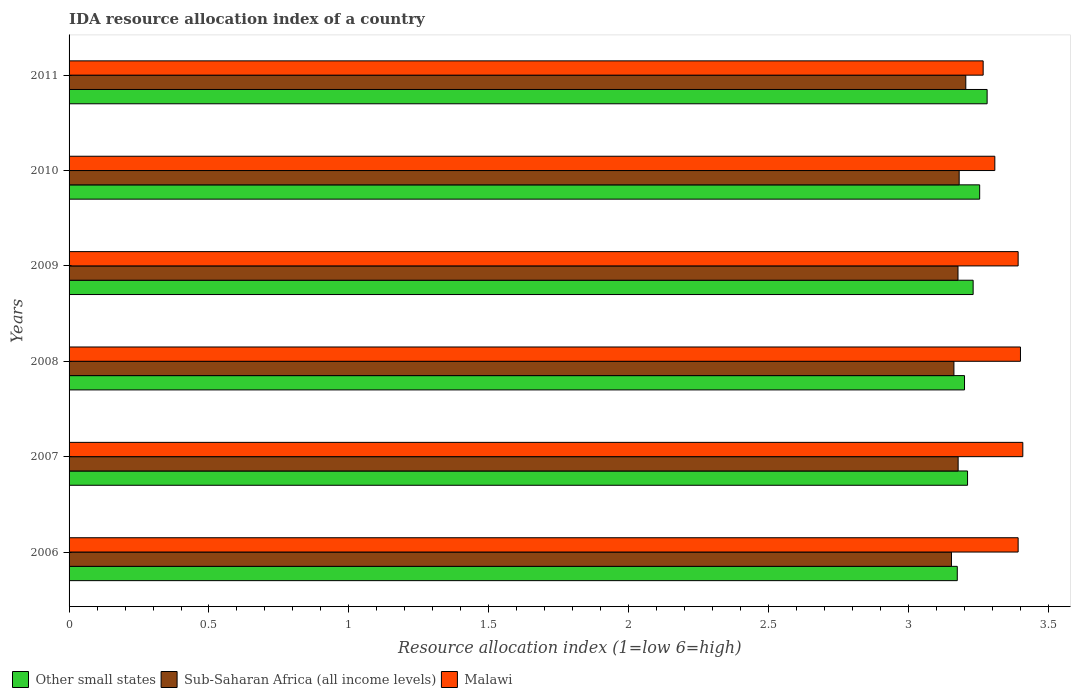Are the number of bars per tick equal to the number of legend labels?
Make the answer very short. Yes. Are the number of bars on each tick of the Y-axis equal?
Make the answer very short. Yes. How many bars are there on the 1st tick from the top?
Provide a short and direct response. 3. What is the label of the 1st group of bars from the top?
Your answer should be compact. 2011. In how many cases, is the number of bars for a given year not equal to the number of legend labels?
Offer a terse response. 0. Across all years, what is the maximum IDA resource allocation index in Other small states?
Your response must be concise. 3.28. Across all years, what is the minimum IDA resource allocation index in Other small states?
Your answer should be very brief. 3.17. What is the total IDA resource allocation index in Malawi in the graph?
Your response must be concise. 20.17. What is the difference between the IDA resource allocation index in Sub-Saharan Africa (all income levels) in 2006 and that in 2011?
Make the answer very short. -0.05. What is the difference between the IDA resource allocation index in Other small states in 2006 and the IDA resource allocation index in Malawi in 2011?
Make the answer very short. -0.09. What is the average IDA resource allocation index in Malawi per year?
Offer a very short reply. 3.36. In the year 2010, what is the difference between the IDA resource allocation index in Other small states and IDA resource allocation index in Sub-Saharan Africa (all income levels)?
Keep it short and to the point. 0.07. What is the ratio of the IDA resource allocation index in Sub-Saharan Africa (all income levels) in 2008 to that in 2009?
Your response must be concise. 1. Is the difference between the IDA resource allocation index in Other small states in 2006 and 2010 greater than the difference between the IDA resource allocation index in Sub-Saharan Africa (all income levels) in 2006 and 2010?
Give a very brief answer. No. What is the difference between the highest and the second highest IDA resource allocation index in Other small states?
Offer a terse response. 0.03. What is the difference between the highest and the lowest IDA resource allocation index in Malawi?
Keep it short and to the point. 0.14. What does the 3rd bar from the top in 2009 represents?
Your answer should be compact. Other small states. What does the 2nd bar from the bottom in 2007 represents?
Ensure brevity in your answer.  Sub-Saharan Africa (all income levels). Is it the case that in every year, the sum of the IDA resource allocation index in Other small states and IDA resource allocation index in Sub-Saharan Africa (all income levels) is greater than the IDA resource allocation index in Malawi?
Offer a terse response. Yes. How many bars are there?
Ensure brevity in your answer.  18. What is the difference between two consecutive major ticks on the X-axis?
Make the answer very short. 0.5. Are the values on the major ticks of X-axis written in scientific E-notation?
Your answer should be compact. No. Does the graph contain any zero values?
Ensure brevity in your answer.  No. Does the graph contain grids?
Offer a terse response. No. How are the legend labels stacked?
Your answer should be very brief. Horizontal. What is the title of the graph?
Offer a very short reply. IDA resource allocation index of a country. Does "Maldives" appear as one of the legend labels in the graph?
Give a very brief answer. No. What is the label or title of the X-axis?
Provide a short and direct response. Resource allocation index (1=low 6=high). What is the Resource allocation index (1=low 6=high) in Other small states in 2006?
Give a very brief answer. 3.17. What is the Resource allocation index (1=low 6=high) of Sub-Saharan Africa (all income levels) in 2006?
Your response must be concise. 3.15. What is the Resource allocation index (1=low 6=high) in Malawi in 2006?
Your answer should be very brief. 3.39. What is the Resource allocation index (1=low 6=high) of Other small states in 2007?
Your answer should be compact. 3.21. What is the Resource allocation index (1=low 6=high) in Sub-Saharan Africa (all income levels) in 2007?
Keep it short and to the point. 3.18. What is the Resource allocation index (1=low 6=high) of Malawi in 2007?
Offer a terse response. 3.41. What is the Resource allocation index (1=low 6=high) in Sub-Saharan Africa (all income levels) in 2008?
Make the answer very short. 3.16. What is the Resource allocation index (1=low 6=high) in Other small states in 2009?
Provide a succinct answer. 3.23. What is the Resource allocation index (1=low 6=high) of Sub-Saharan Africa (all income levels) in 2009?
Offer a very short reply. 3.18. What is the Resource allocation index (1=low 6=high) in Malawi in 2009?
Your answer should be compact. 3.39. What is the Resource allocation index (1=low 6=high) of Other small states in 2010?
Make the answer very short. 3.25. What is the Resource allocation index (1=low 6=high) of Sub-Saharan Africa (all income levels) in 2010?
Your answer should be compact. 3.18. What is the Resource allocation index (1=low 6=high) in Malawi in 2010?
Your answer should be compact. 3.31. What is the Resource allocation index (1=low 6=high) in Other small states in 2011?
Keep it short and to the point. 3.28. What is the Resource allocation index (1=low 6=high) of Sub-Saharan Africa (all income levels) in 2011?
Your answer should be compact. 3.2. What is the Resource allocation index (1=low 6=high) of Malawi in 2011?
Keep it short and to the point. 3.27. Across all years, what is the maximum Resource allocation index (1=low 6=high) of Other small states?
Keep it short and to the point. 3.28. Across all years, what is the maximum Resource allocation index (1=low 6=high) in Sub-Saharan Africa (all income levels)?
Provide a succinct answer. 3.2. Across all years, what is the maximum Resource allocation index (1=low 6=high) in Malawi?
Provide a short and direct response. 3.41. Across all years, what is the minimum Resource allocation index (1=low 6=high) of Other small states?
Provide a short and direct response. 3.17. Across all years, what is the minimum Resource allocation index (1=low 6=high) in Sub-Saharan Africa (all income levels)?
Ensure brevity in your answer.  3.15. Across all years, what is the minimum Resource allocation index (1=low 6=high) in Malawi?
Provide a short and direct response. 3.27. What is the total Resource allocation index (1=low 6=high) of Other small states in the graph?
Keep it short and to the point. 19.35. What is the total Resource allocation index (1=low 6=high) of Sub-Saharan Africa (all income levels) in the graph?
Provide a short and direct response. 19.06. What is the total Resource allocation index (1=low 6=high) of Malawi in the graph?
Your response must be concise. 20.17. What is the difference between the Resource allocation index (1=low 6=high) of Other small states in 2006 and that in 2007?
Your answer should be compact. -0.04. What is the difference between the Resource allocation index (1=low 6=high) of Sub-Saharan Africa (all income levels) in 2006 and that in 2007?
Provide a succinct answer. -0.02. What is the difference between the Resource allocation index (1=low 6=high) in Malawi in 2006 and that in 2007?
Keep it short and to the point. -0.02. What is the difference between the Resource allocation index (1=low 6=high) in Other small states in 2006 and that in 2008?
Your answer should be very brief. -0.03. What is the difference between the Resource allocation index (1=low 6=high) in Sub-Saharan Africa (all income levels) in 2006 and that in 2008?
Offer a terse response. -0.01. What is the difference between the Resource allocation index (1=low 6=high) of Malawi in 2006 and that in 2008?
Your answer should be compact. -0.01. What is the difference between the Resource allocation index (1=low 6=high) in Other small states in 2006 and that in 2009?
Make the answer very short. -0.06. What is the difference between the Resource allocation index (1=low 6=high) of Sub-Saharan Africa (all income levels) in 2006 and that in 2009?
Give a very brief answer. -0.02. What is the difference between the Resource allocation index (1=low 6=high) of Other small states in 2006 and that in 2010?
Your answer should be compact. -0.08. What is the difference between the Resource allocation index (1=low 6=high) in Sub-Saharan Africa (all income levels) in 2006 and that in 2010?
Provide a succinct answer. -0.03. What is the difference between the Resource allocation index (1=low 6=high) of Malawi in 2006 and that in 2010?
Your answer should be compact. 0.08. What is the difference between the Resource allocation index (1=low 6=high) in Other small states in 2006 and that in 2011?
Provide a succinct answer. -0.11. What is the difference between the Resource allocation index (1=low 6=high) in Sub-Saharan Africa (all income levels) in 2006 and that in 2011?
Offer a terse response. -0.05. What is the difference between the Resource allocation index (1=low 6=high) in Malawi in 2006 and that in 2011?
Offer a very short reply. 0.12. What is the difference between the Resource allocation index (1=low 6=high) in Other small states in 2007 and that in 2008?
Your answer should be compact. 0.01. What is the difference between the Resource allocation index (1=low 6=high) in Sub-Saharan Africa (all income levels) in 2007 and that in 2008?
Make the answer very short. 0.02. What is the difference between the Resource allocation index (1=low 6=high) of Malawi in 2007 and that in 2008?
Make the answer very short. 0.01. What is the difference between the Resource allocation index (1=low 6=high) in Other small states in 2007 and that in 2009?
Your response must be concise. -0.02. What is the difference between the Resource allocation index (1=low 6=high) in Malawi in 2007 and that in 2009?
Ensure brevity in your answer.  0.02. What is the difference between the Resource allocation index (1=low 6=high) in Other small states in 2007 and that in 2010?
Provide a short and direct response. -0.04. What is the difference between the Resource allocation index (1=low 6=high) in Sub-Saharan Africa (all income levels) in 2007 and that in 2010?
Make the answer very short. -0. What is the difference between the Resource allocation index (1=low 6=high) in Other small states in 2007 and that in 2011?
Give a very brief answer. -0.07. What is the difference between the Resource allocation index (1=low 6=high) in Sub-Saharan Africa (all income levels) in 2007 and that in 2011?
Your answer should be very brief. -0.03. What is the difference between the Resource allocation index (1=low 6=high) of Malawi in 2007 and that in 2011?
Your response must be concise. 0.14. What is the difference between the Resource allocation index (1=low 6=high) of Other small states in 2008 and that in 2009?
Your answer should be compact. -0.03. What is the difference between the Resource allocation index (1=low 6=high) of Sub-Saharan Africa (all income levels) in 2008 and that in 2009?
Your answer should be compact. -0.01. What is the difference between the Resource allocation index (1=low 6=high) in Malawi in 2008 and that in 2009?
Offer a terse response. 0.01. What is the difference between the Resource allocation index (1=low 6=high) of Other small states in 2008 and that in 2010?
Ensure brevity in your answer.  -0.05. What is the difference between the Resource allocation index (1=low 6=high) of Sub-Saharan Africa (all income levels) in 2008 and that in 2010?
Offer a very short reply. -0.02. What is the difference between the Resource allocation index (1=low 6=high) of Malawi in 2008 and that in 2010?
Your answer should be compact. 0.09. What is the difference between the Resource allocation index (1=low 6=high) in Other small states in 2008 and that in 2011?
Your response must be concise. -0.08. What is the difference between the Resource allocation index (1=low 6=high) in Sub-Saharan Africa (all income levels) in 2008 and that in 2011?
Offer a terse response. -0.04. What is the difference between the Resource allocation index (1=low 6=high) in Malawi in 2008 and that in 2011?
Provide a succinct answer. 0.13. What is the difference between the Resource allocation index (1=low 6=high) in Other small states in 2009 and that in 2010?
Make the answer very short. -0.02. What is the difference between the Resource allocation index (1=low 6=high) in Sub-Saharan Africa (all income levels) in 2009 and that in 2010?
Keep it short and to the point. -0. What is the difference between the Resource allocation index (1=low 6=high) of Malawi in 2009 and that in 2010?
Your response must be concise. 0.08. What is the difference between the Resource allocation index (1=low 6=high) in Sub-Saharan Africa (all income levels) in 2009 and that in 2011?
Provide a succinct answer. -0.03. What is the difference between the Resource allocation index (1=low 6=high) of Other small states in 2010 and that in 2011?
Provide a short and direct response. -0.03. What is the difference between the Resource allocation index (1=low 6=high) in Sub-Saharan Africa (all income levels) in 2010 and that in 2011?
Make the answer very short. -0.02. What is the difference between the Resource allocation index (1=low 6=high) of Malawi in 2010 and that in 2011?
Give a very brief answer. 0.04. What is the difference between the Resource allocation index (1=low 6=high) of Other small states in 2006 and the Resource allocation index (1=low 6=high) of Sub-Saharan Africa (all income levels) in 2007?
Your response must be concise. -0. What is the difference between the Resource allocation index (1=low 6=high) in Other small states in 2006 and the Resource allocation index (1=low 6=high) in Malawi in 2007?
Your answer should be very brief. -0.23. What is the difference between the Resource allocation index (1=low 6=high) in Sub-Saharan Africa (all income levels) in 2006 and the Resource allocation index (1=low 6=high) in Malawi in 2007?
Offer a terse response. -0.26. What is the difference between the Resource allocation index (1=low 6=high) in Other small states in 2006 and the Resource allocation index (1=low 6=high) in Sub-Saharan Africa (all income levels) in 2008?
Your response must be concise. 0.01. What is the difference between the Resource allocation index (1=low 6=high) of Other small states in 2006 and the Resource allocation index (1=low 6=high) of Malawi in 2008?
Offer a terse response. -0.23. What is the difference between the Resource allocation index (1=low 6=high) in Sub-Saharan Africa (all income levels) in 2006 and the Resource allocation index (1=low 6=high) in Malawi in 2008?
Make the answer very short. -0.25. What is the difference between the Resource allocation index (1=low 6=high) of Other small states in 2006 and the Resource allocation index (1=low 6=high) of Sub-Saharan Africa (all income levels) in 2009?
Offer a terse response. -0. What is the difference between the Resource allocation index (1=low 6=high) in Other small states in 2006 and the Resource allocation index (1=low 6=high) in Malawi in 2009?
Give a very brief answer. -0.22. What is the difference between the Resource allocation index (1=low 6=high) of Sub-Saharan Africa (all income levels) in 2006 and the Resource allocation index (1=low 6=high) of Malawi in 2009?
Make the answer very short. -0.24. What is the difference between the Resource allocation index (1=low 6=high) of Other small states in 2006 and the Resource allocation index (1=low 6=high) of Sub-Saharan Africa (all income levels) in 2010?
Provide a succinct answer. -0.01. What is the difference between the Resource allocation index (1=low 6=high) of Other small states in 2006 and the Resource allocation index (1=low 6=high) of Malawi in 2010?
Your response must be concise. -0.13. What is the difference between the Resource allocation index (1=low 6=high) in Sub-Saharan Africa (all income levels) in 2006 and the Resource allocation index (1=low 6=high) in Malawi in 2010?
Your answer should be very brief. -0.15. What is the difference between the Resource allocation index (1=low 6=high) of Other small states in 2006 and the Resource allocation index (1=low 6=high) of Sub-Saharan Africa (all income levels) in 2011?
Provide a short and direct response. -0.03. What is the difference between the Resource allocation index (1=low 6=high) in Other small states in 2006 and the Resource allocation index (1=low 6=high) in Malawi in 2011?
Offer a very short reply. -0.09. What is the difference between the Resource allocation index (1=low 6=high) in Sub-Saharan Africa (all income levels) in 2006 and the Resource allocation index (1=low 6=high) in Malawi in 2011?
Provide a short and direct response. -0.11. What is the difference between the Resource allocation index (1=low 6=high) in Other small states in 2007 and the Resource allocation index (1=low 6=high) in Sub-Saharan Africa (all income levels) in 2008?
Give a very brief answer. 0.05. What is the difference between the Resource allocation index (1=low 6=high) in Other small states in 2007 and the Resource allocation index (1=low 6=high) in Malawi in 2008?
Give a very brief answer. -0.19. What is the difference between the Resource allocation index (1=low 6=high) of Sub-Saharan Africa (all income levels) in 2007 and the Resource allocation index (1=low 6=high) of Malawi in 2008?
Give a very brief answer. -0.22. What is the difference between the Resource allocation index (1=low 6=high) in Other small states in 2007 and the Resource allocation index (1=low 6=high) in Sub-Saharan Africa (all income levels) in 2009?
Provide a succinct answer. 0.03. What is the difference between the Resource allocation index (1=low 6=high) in Other small states in 2007 and the Resource allocation index (1=low 6=high) in Malawi in 2009?
Make the answer very short. -0.18. What is the difference between the Resource allocation index (1=low 6=high) of Sub-Saharan Africa (all income levels) in 2007 and the Resource allocation index (1=low 6=high) of Malawi in 2009?
Your response must be concise. -0.21. What is the difference between the Resource allocation index (1=low 6=high) of Other small states in 2007 and the Resource allocation index (1=low 6=high) of Sub-Saharan Africa (all income levels) in 2010?
Make the answer very short. 0.03. What is the difference between the Resource allocation index (1=low 6=high) in Other small states in 2007 and the Resource allocation index (1=low 6=high) in Malawi in 2010?
Ensure brevity in your answer.  -0.1. What is the difference between the Resource allocation index (1=low 6=high) of Sub-Saharan Africa (all income levels) in 2007 and the Resource allocation index (1=low 6=high) of Malawi in 2010?
Keep it short and to the point. -0.13. What is the difference between the Resource allocation index (1=low 6=high) of Other small states in 2007 and the Resource allocation index (1=low 6=high) of Sub-Saharan Africa (all income levels) in 2011?
Your response must be concise. 0.01. What is the difference between the Resource allocation index (1=low 6=high) in Other small states in 2007 and the Resource allocation index (1=low 6=high) in Malawi in 2011?
Keep it short and to the point. -0.06. What is the difference between the Resource allocation index (1=low 6=high) in Sub-Saharan Africa (all income levels) in 2007 and the Resource allocation index (1=low 6=high) in Malawi in 2011?
Your response must be concise. -0.09. What is the difference between the Resource allocation index (1=low 6=high) of Other small states in 2008 and the Resource allocation index (1=low 6=high) of Sub-Saharan Africa (all income levels) in 2009?
Provide a short and direct response. 0.02. What is the difference between the Resource allocation index (1=low 6=high) in Other small states in 2008 and the Resource allocation index (1=low 6=high) in Malawi in 2009?
Offer a very short reply. -0.19. What is the difference between the Resource allocation index (1=low 6=high) in Sub-Saharan Africa (all income levels) in 2008 and the Resource allocation index (1=low 6=high) in Malawi in 2009?
Your answer should be very brief. -0.23. What is the difference between the Resource allocation index (1=low 6=high) in Other small states in 2008 and the Resource allocation index (1=low 6=high) in Sub-Saharan Africa (all income levels) in 2010?
Your response must be concise. 0.02. What is the difference between the Resource allocation index (1=low 6=high) in Other small states in 2008 and the Resource allocation index (1=low 6=high) in Malawi in 2010?
Ensure brevity in your answer.  -0.11. What is the difference between the Resource allocation index (1=low 6=high) in Sub-Saharan Africa (all income levels) in 2008 and the Resource allocation index (1=low 6=high) in Malawi in 2010?
Your answer should be compact. -0.15. What is the difference between the Resource allocation index (1=low 6=high) in Other small states in 2008 and the Resource allocation index (1=low 6=high) in Sub-Saharan Africa (all income levels) in 2011?
Keep it short and to the point. -0. What is the difference between the Resource allocation index (1=low 6=high) of Other small states in 2008 and the Resource allocation index (1=low 6=high) of Malawi in 2011?
Offer a very short reply. -0.07. What is the difference between the Resource allocation index (1=low 6=high) in Sub-Saharan Africa (all income levels) in 2008 and the Resource allocation index (1=low 6=high) in Malawi in 2011?
Offer a very short reply. -0.1. What is the difference between the Resource allocation index (1=low 6=high) in Other small states in 2009 and the Resource allocation index (1=low 6=high) in Sub-Saharan Africa (all income levels) in 2010?
Offer a terse response. 0.05. What is the difference between the Resource allocation index (1=low 6=high) in Other small states in 2009 and the Resource allocation index (1=low 6=high) in Malawi in 2010?
Provide a short and direct response. -0.08. What is the difference between the Resource allocation index (1=low 6=high) of Sub-Saharan Africa (all income levels) in 2009 and the Resource allocation index (1=low 6=high) of Malawi in 2010?
Your response must be concise. -0.13. What is the difference between the Resource allocation index (1=low 6=high) of Other small states in 2009 and the Resource allocation index (1=low 6=high) of Sub-Saharan Africa (all income levels) in 2011?
Offer a very short reply. 0.03. What is the difference between the Resource allocation index (1=low 6=high) in Other small states in 2009 and the Resource allocation index (1=low 6=high) in Malawi in 2011?
Your answer should be very brief. -0.04. What is the difference between the Resource allocation index (1=low 6=high) of Sub-Saharan Africa (all income levels) in 2009 and the Resource allocation index (1=low 6=high) of Malawi in 2011?
Your response must be concise. -0.09. What is the difference between the Resource allocation index (1=low 6=high) of Other small states in 2010 and the Resource allocation index (1=low 6=high) of Sub-Saharan Africa (all income levels) in 2011?
Your answer should be very brief. 0.05. What is the difference between the Resource allocation index (1=low 6=high) of Other small states in 2010 and the Resource allocation index (1=low 6=high) of Malawi in 2011?
Provide a short and direct response. -0.01. What is the difference between the Resource allocation index (1=low 6=high) in Sub-Saharan Africa (all income levels) in 2010 and the Resource allocation index (1=low 6=high) in Malawi in 2011?
Keep it short and to the point. -0.09. What is the average Resource allocation index (1=low 6=high) in Other small states per year?
Keep it short and to the point. 3.23. What is the average Resource allocation index (1=low 6=high) of Sub-Saharan Africa (all income levels) per year?
Keep it short and to the point. 3.18. What is the average Resource allocation index (1=low 6=high) in Malawi per year?
Your answer should be compact. 3.36. In the year 2006, what is the difference between the Resource allocation index (1=low 6=high) of Other small states and Resource allocation index (1=low 6=high) of Sub-Saharan Africa (all income levels)?
Your answer should be very brief. 0.02. In the year 2006, what is the difference between the Resource allocation index (1=low 6=high) in Other small states and Resource allocation index (1=low 6=high) in Malawi?
Your response must be concise. -0.22. In the year 2006, what is the difference between the Resource allocation index (1=low 6=high) in Sub-Saharan Africa (all income levels) and Resource allocation index (1=low 6=high) in Malawi?
Offer a terse response. -0.24. In the year 2007, what is the difference between the Resource allocation index (1=low 6=high) in Other small states and Resource allocation index (1=low 6=high) in Sub-Saharan Africa (all income levels)?
Offer a terse response. 0.03. In the year 2007, what is the difference between the Resource allocation index (1=low 6=high) of Other small states and Resource allocation index (1=low 6=high) of Malawi?
Provide a succinct answer. -0.2. In the year 2007, what is the difference between the Resource allocation index (1=low 6=high) in Sub-Saharan Africa (all income levels) and Resource allocation index (1=low 6=high) in Malawi?
Offer a terse response. -0.23. In the year 2008, what is the difference between the Resource allocation index (1=low 6=high) in Other small states and Resource allocation index (1=low 6=high) in Sub-Saharan Africa (all income levels)?
Provide a short and direct response. 0.04. In the year 2008, what is the difference between the Resource allocation index (1=low 6=high) of Other small states and Resource allocation index (1=low 6=high) of Malawi?
Keep it short and to the point. -0.2. In the year 2008, what is the difference between the Resource allocation index (1=low 6=high) in Sub-Saharan Africa (all income levels) and Resource allocation index (1=low 6=high) in Malawi?
Offer a terse response. -0.24. In the year 2009, what is the difference between the Resource allocation index (1=low 6=high) in Other small states and Resource allocation index (1=low 6=high) in Sub-Saharan Africa (all income levels)?
Make the answer very short. 0.05. In the year 2009, what is the difference between the Resource allocation index (1=low 6=high) of Other small states and Resource allocation index (1=low 6=high) of Malawi?
Provide a succinct answer. -0.16. In the year 2009, what is the difference between the Resource allocation index (1=low 6=high) of Sub-Saharan Africa (all income levels) and Resource allocation index (1=low 6=high) of Malawi?
Provide a short and direct response. -0.21. In the year 2010, what is the difference between the Resource allocation index (1=low 6=high) in Other small states and Resource allocation index (1=low 6=high) in Sub-Saharan Africa (all income levels)?
Provide a succinct answer. 0.07. In the year 2010, what is the difference between the Resource allocation index (1=low 6=high) of Other small states and Resource allocation index (1=low 6=high) of Malawi?
Offer a very short reply. -0.05. In the year 2010, what is the difference between the Resource allocation index (1=low 6=high) in Sub-Saharan Africa (all income levels) and Resource allocation index (1=low 6=high) in Malawi?
Provide a short and direct response. -0.13. In the year 2011, what is the difference between the Resource allocation index (1=low 6=high) of Other small states and Resource allocation index (1=low 6=high) of Sub-Saharan Africa (all income levels)?
Provide a succinct answer. 0.08. In the year 2011, what is the difference between the Resource allocation index (1=low 6=high) of Other small states and Resource allocation index (1=low 6=high) of Malawi?
Offer a terse response. 0.01. In the year 2011, what is the difference between the Resource allocation index (1=low 6=high) in Sub-Saharan Africa (all income levels) and Resource allocation index (1=low 6=high) in Malawi?
Provide a succinct answer. -0.06. What is the ratio of the Resource allocation index (1=low 6=high) in Sub-Saharan Africa (all income levels) in 2006 to that in 2007?
Your answer should be very brief. 0.99. What is the ratio of the Resource allocation index (1=low 6=high) of Other small states in 2006 to that in 2008?
Keep it short and to the point. 0.99. What is the ratio of the Resource allocation index (1=low 6=high) of Sub-Saharan Africa (all income levels) in 2006 to that in 2008?
Your response must be concise. 1. What is the ratio of the Resource allocation index (1=low 6=high) of Other small states in 2006 to that in 2009?
Your response must be concise. 0.98. What is the ratio of the Resource allocation index (1=low 6=high) in Sub-Saharan Africa (all income levels) in 2006 to that in 2009?
Provide a succinct answer. 0.99. What is the ratio of the Resource allocation index (1=low 6=high) in Other small states in 2006 to that in 2010?
Give a very brief answer. 0.98. What is the ratio of the Resource allocation index (1=low 6=high) in Malawi in 2006 to that in 2010?
Offer a terse response. 1.03. What is the ratio of the Resource allocation index (1=low 6=high) of Other small states in 2006 to that in 2011?
Your answer should be compact. 0.97. What is the ratio of the Resource allocation index (1=low 6=high) in Malawi in 2006 to that in 2011?
Keep it short and to the point. 1.04. What is the ratio of the Resource allocation index (1=low 6=high) of Other small states in 2007 to that in 2008?
Give a very brief answer. 1. What is the ratio of the Resource allocation index (1=low 6=high) of Malawi in 2007 to that in 2008?
Offer a terse response. 1. What is the ratio of the Resource allocation index (1=low 6=high) in Sub-Saharan Africa (all income levels) in 2007 to that in 2009?
Ensure brevity in your answer.  1. What is the ratio of the Resource allocation index (1=low 6=high) in Malawi in 2007 to that in 2009?
Your answer should be compact. 1. What is the ratio of the Resource allocation index (1=low 6=high) of Other small states in 2007 to that in 2010?
Your answer should be compact. 0.99. What is the ratio of the Resource allocation index (1=low 6=high) in Sub-Saharan Africa (all income levels) in 2007 to that in 2010?
Give a very brief answer. 1. What is the ratio of the Resource allocation index (1=low 6=high) in Malawi in 2007 to that in 2010?
Offer a terse response. 1.03. What is the ratio of the Resource allocation index (1=low 6=high) in Other small states in 2007 to that in 2011?
Your answer should be compact. 0.98. What is the ratio of the Resource allocation index (1=low 6=high) of Malawi in 2007 to that in 2011?
Provide a short and direct response. 1.04. What is the ratio of the Resource allocation index (1=low 6=high) of Other small states in 2008 to that in 2009?
Your answer should be compact. 0.99. What is the ratio of the Resource allocation index (1=low 6=high) of Sub-Saharan Africa (all income levels) in 2008 to that in 2009?
Offer a terse response. 1. What is the ratio of the Resource allocation index (1=low 6=high) of Malawi in 2008 to that in 2009?
Your response must be concise. 1. What is the ratio of the Resource allocation index (1=low 6=high) in Other small states in 2008 to that in 2010?
Provide a succinct answer. 0.98. What is the ratio of the Resource allocation index (1=low 6=high) of Sub-Saharan Africa (all income levels) in 2008 to that in 2010?
Your response must be concise. 0.99. What is the ratio of the Resource allocation index (1=low 6=high) of Malawi in 2008 to that in 2010?
Offer a very short reply. 1.03. What is the ratio of the Resource allocation index (1=low 6=high) in Other small states in 2008 to that in 2011?
Your answer should be very brief. 0.98. What is the ratio of the Resource allocation index (1=low 6=high) in Sub-Saharan Africa (all income levels) in 2008 to that in 2011?
Your answer should be compact. 0.99. What is the ratio of the Resource allocation index (1=low 6=high) in Malawi in 2008 to that in 2011?
Your response must be concise. 1.04. What is the ratio of the Resource allocation index (1=low 6=high) in Malawi in 2009 to that in 2010?
Your answer should be very brief. 1.03. What is the ratio of the Resource allocation index (1=low 6=high) in Other small states in 2009 to that in 2011?
Ensure brevity in your answer.  0.98. What is the ratio of the Resource allocation index (1=low 6=high) in Malawi in 2009 to that in 2011?
Offer a terse response. 1.04. What is the ratio of the Resource allocation index (1=low 6=high) of Malawi in 2010 to that in 2011?
Make the answer very short. 1.01. What is the difference between the highest and the second highest Resource allocation index (1=low 6=high) of Other small states?
Give a very brief answer. 0.03. What is the difference between the highest and the second highest Resource allocation index (1=low 6=high) of Sub-Saharan Africa (all income levels)?
Provide a succinct answer. 0.02. What is the difference between the highest and the second highest Resource allocation index (1=low 6=high) of Malawi?
Provide a short and direct response. 0.01. What is the difference between the highest and the lowest Resource allocation index (1=low 6=high) of Other small states?
Provide a succinct answer. 0.11. What is the difference between the highest and the lowest Resource allocation index (1=low 6=high) in Sub-Saharan Africa (all income levels)?
Offer a very short reply. 0.05. What is the difference between the highest and the lowest Resource allocation index (1=low 6=high) in Malawi?
Provide a short and direct response. 0.14. 